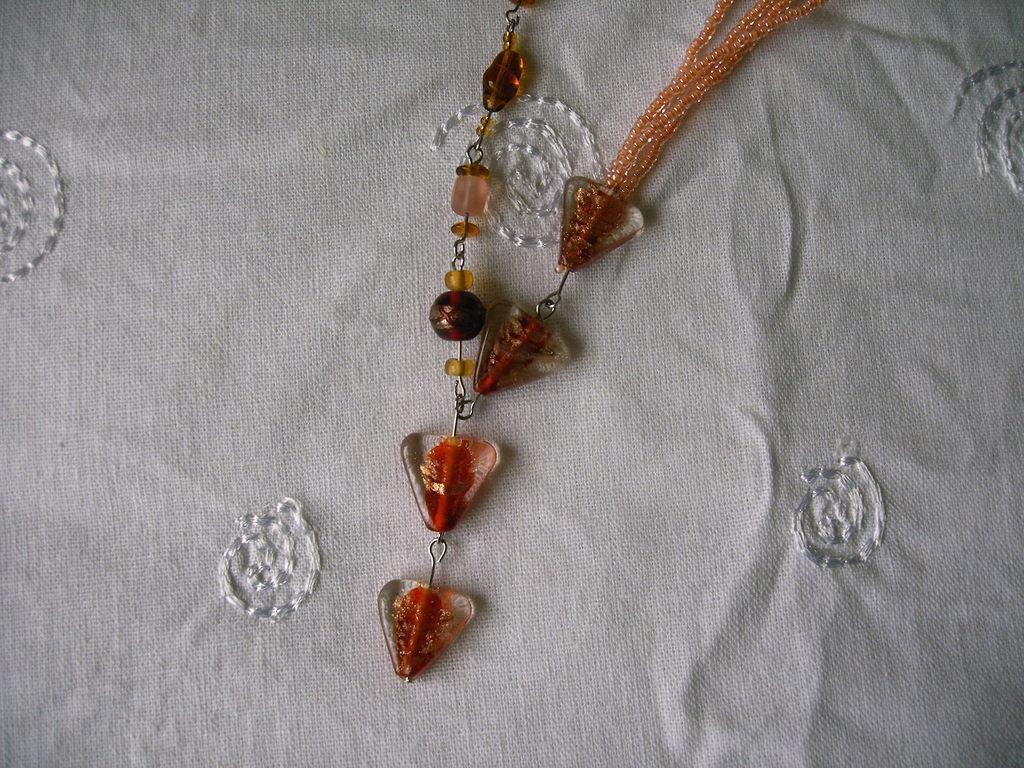Describe this image in one or two sentences. In this image I can see a white color cloth and on the cloth I can see a colorful chain 